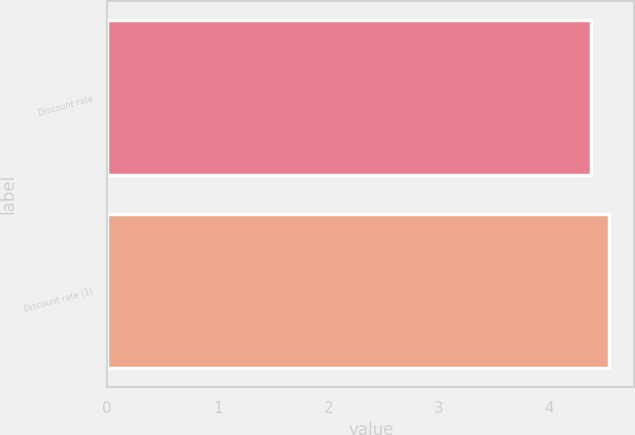Convert chart to OTSL. <chart><loc_0><loc_0><loc_500><loc_500><bar_chart><fcel>Discount rate<fcel>Discount rate (1)<nl><fcel>4.38<fcel>4.54<nl></chart> 